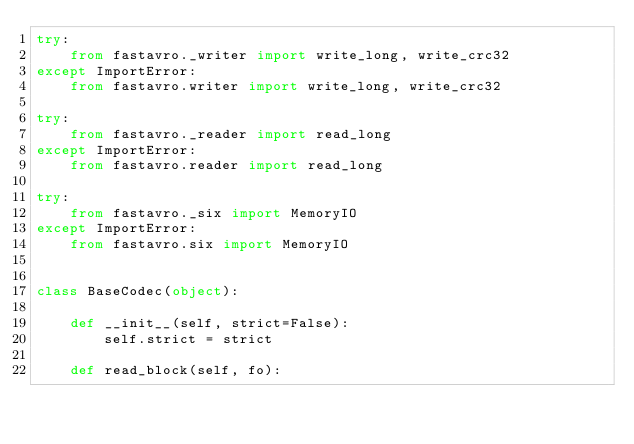Convert code to text. <code><loc_0><loc_0><loc_500><loc_500><_Python_>try:
    from fastavro._writer import write_long, write_crc32
except ImportError:
    from fastavro.writer import write_long, write_crc32

try:
    from fastavro._reader import read_long
except ImportError:
    from fastavro.reader import read_long

try:
    from fastavro._six import MemoryIO
except ImportError:
    from fastavro.six import MemoryIO


class BaseCodec(object):

    def __init__(self, strict=False):
        self.strict = strict

    def read_block(self, fo):</code> 